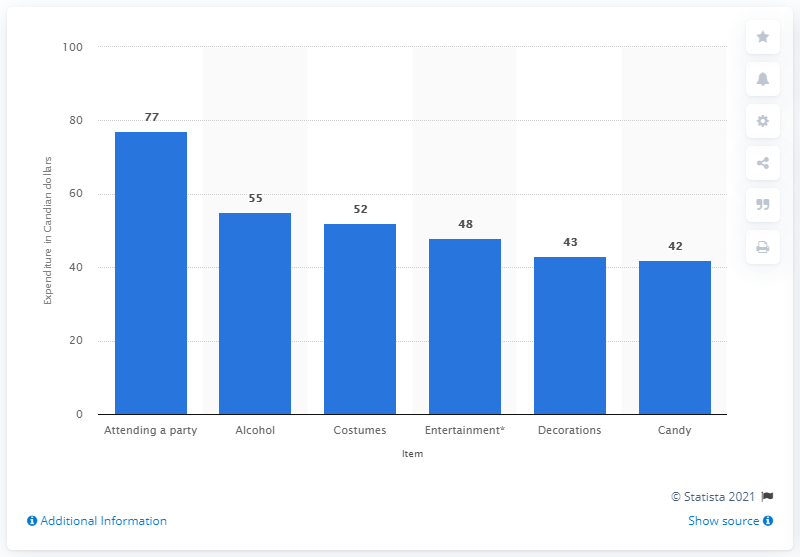Mention a couple of crucial points in this snapshot. In 2015, Canadians had planned to spend 52 dollars on costumes. In 2015, Canadians anticipated spending 42 dollars on candy for Halloween. 